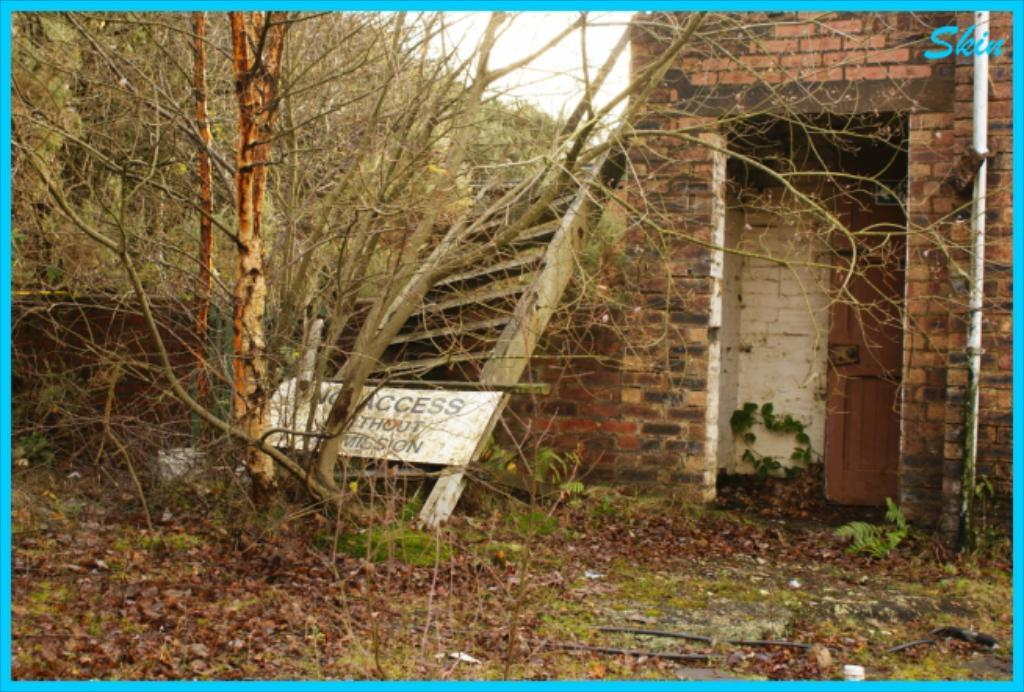<image>
Present a compact description of the photo's key features. A fallen white sign next to a decrepit building says No Access. 